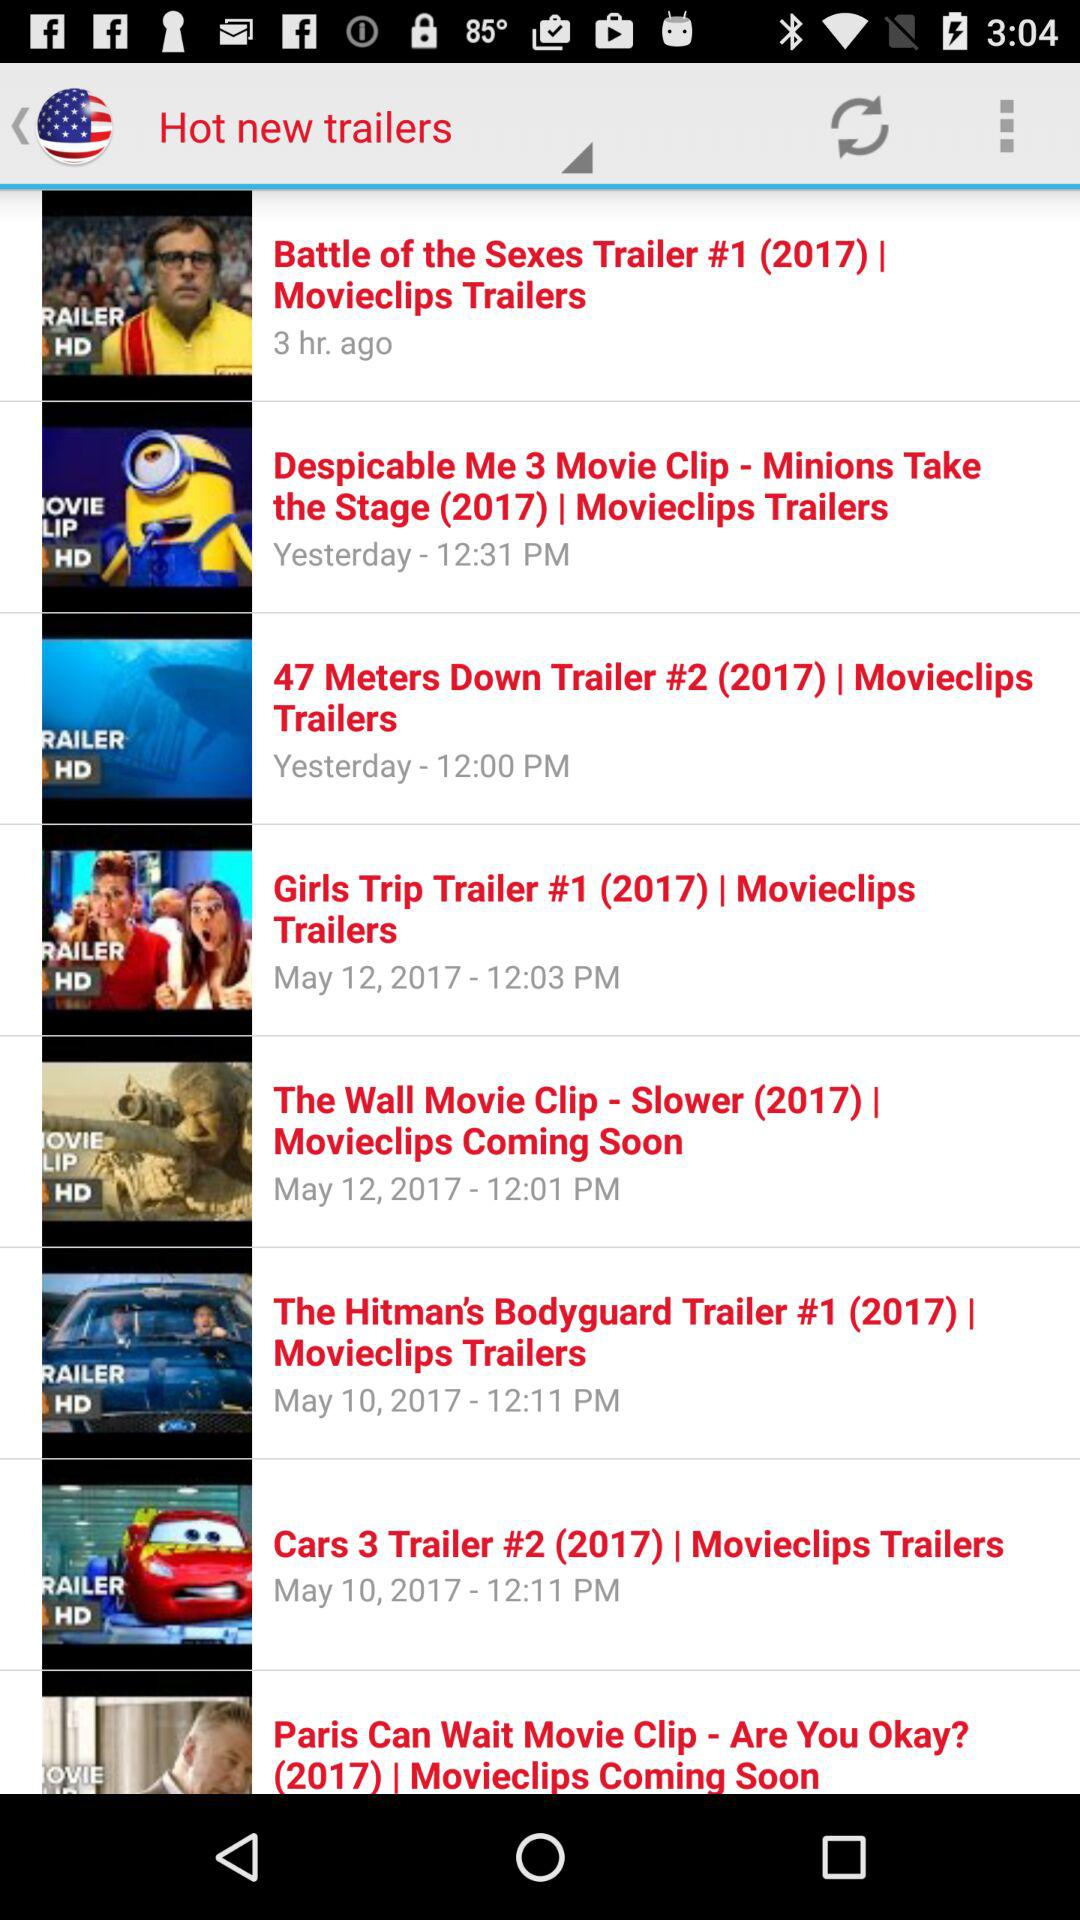What is the release date of the trailer titled "Girls Trip Trailer #1 (2017)"? The release date is May 12, 2017. 